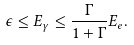<formula> <loc_0><loc_0><loc_500><loc_500>\epsilon \leq E _ { \gamma } \leq \frac { \Gamma } { 1 + \Gamma } E _ { e } .</formula> 